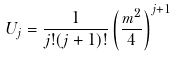Convert formula to latex. <formula><loc_0><loc_0><loc_500><loc_500>U _ { j } = \frac { 1 } { j ! ( j + 1 ) ! } \left ( \frac { m ^ { 2 } } { 4 } \right ) ^ { j + 1 }</formula> 